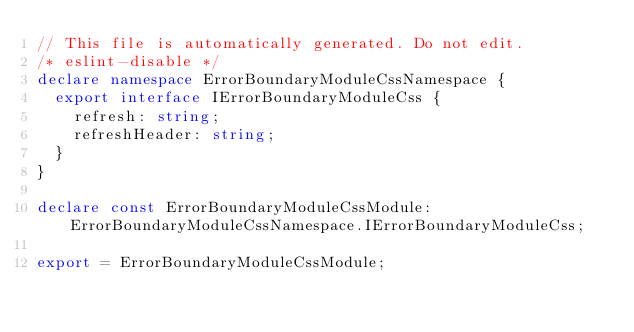Convert code to text. <code><loc_0><loc_0><loc_500><loc_500><_TypeScript_>// This file is automatically generated. Do not edit.
/* eslint-disable */
declare namespace ErrorBoundaryModuleCssNamespace {
  export interface IErrorBoundaryModuleCss {
    refresh: string;
    refreshHeader: string;
  }
}

declare const ErrorBoundaryModuleCssModule: ErrorBoundaryModuleCssNamespace.IErrorBoundaryModuleCss;

export = ErrorBoundaryModuleCssModule;
</code> 